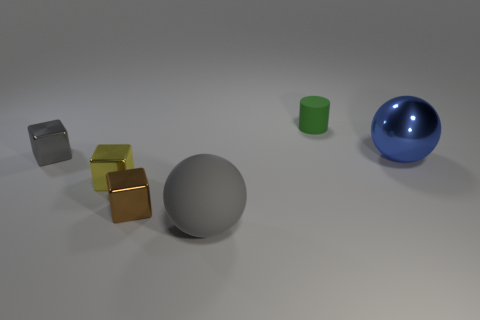Add 3 tiny brown matte cylinders. How many objects exist? 9 Subtract all cylinders. How many objects are left? 5 Add 5 gray matte objects. How many gray matte objects are left? 6 Add 4 big red matte cylinders. How many big red matte cylinders exist? 4 Subtract 0 purple blocks. How many objects are left? 6 Subtract all small cyan metallic spheres. Subtract all metal objects. How many objects are left? 2 